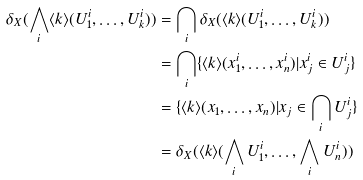Convert formula to latex. <formula><loc_0><loc_0><loc_500><loc_500>\delta _ { X } ( \bigwedge _ { i } \langle k \rangle ( U _ { 1 } ^ { i } , \dots , U _ { k } ^ { i } ) ) & = \bigcap _ { i } \delta _ { X } ( \langle k \rangle ( U _ { 1 } ^ { i } , \dots , U _ { k } ^ { i } ) ) \\ & = \bigcap _ { i } \{ \langle k \rangle ( x _ { 1 } ^ { i } , \dots , x _ { n } ^ { i } ) | x ^ { i } _ { j } \in U ^ { i } _ { j } \} \\ & = \{ \langle k \rangle ( x _ { 1 } , \dots , x _ { n } ) | x _ { j } \in \bigcap _ { i } U ^ { i } _ { j } \} \\ & = \delta _ { X } ( \langle k \rangle ( \bigwedge _ { i } U ^ { i } _ { 1 } , \dots , \bigwedge _ { i } U ^ { i } _ { n } ) )</formula> 